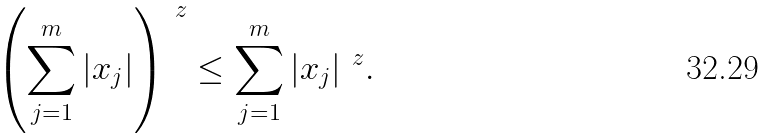<formula> <loc_0><loc_0><loc_500><loc_500>\left ( \sum _ { j = 1 } ^ { m } | x _ { j } | \right ) ^ { \ z } \leq \sum _ { j = 1 } ^ { m } | x _ { j } | ^ { \ z } .</formula> 